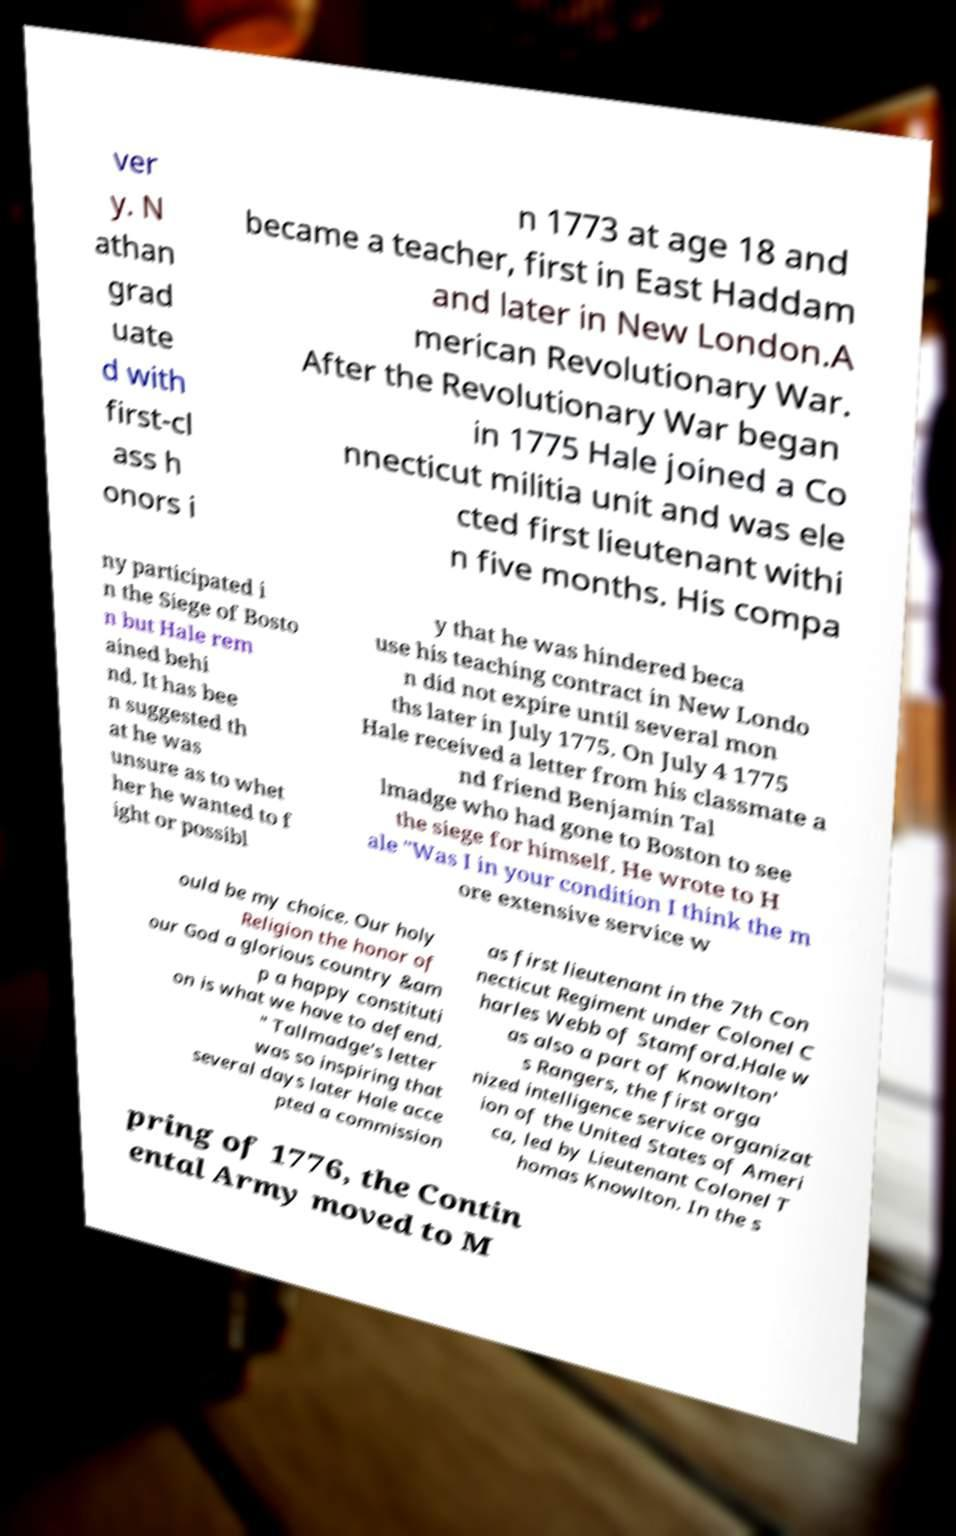Could you extract and type out the text from this image? ver y. N athan grad uate d with first-cl ass h onors i n 1773 at age 18 and became a teacher, first in East Haddam and later in New London.A merican Revolutionary War. After the Revolutionary War began in 1775 Hale joined a Co nnecticut militia unit and was ele cted first lieutenant withi n five months. His compa ny participated i n the Siege of Bosto n but Hale rem ained behi nd. It has bee n suggested th at he was unsure as to whet her he wanted to f ight or possibl y that he was hindered beca use his teaching contract in New Londo n did not expire until several mon ths later in July 1775. On July 4 1775 Hale received a letter from his classmate a nd friend Benjamin Tal lmadge who had gone to Boston to see the siege for himself. He wrote to H ale "Was I in your condition I think the m ore extensive service w ould be my choice. Our holy Religion the honor of our God a glorious country &am p a happy constituti on is what we have to defend. " Tallmadge's letter was so inspiring that several days later Hale acce pted a commission as first lieutenant in the 7th Con necticut Regiment under Colonel C harles Webb of Stamford.Hale w as also a part of Knowlton' s Rangers, the first orga nized intelligence service organizat ion of the United States of Ameri ca, led by Lieutenant Colonel T homas Knowlton. In the s pring of 1776, the Contin ental Army moved to M 